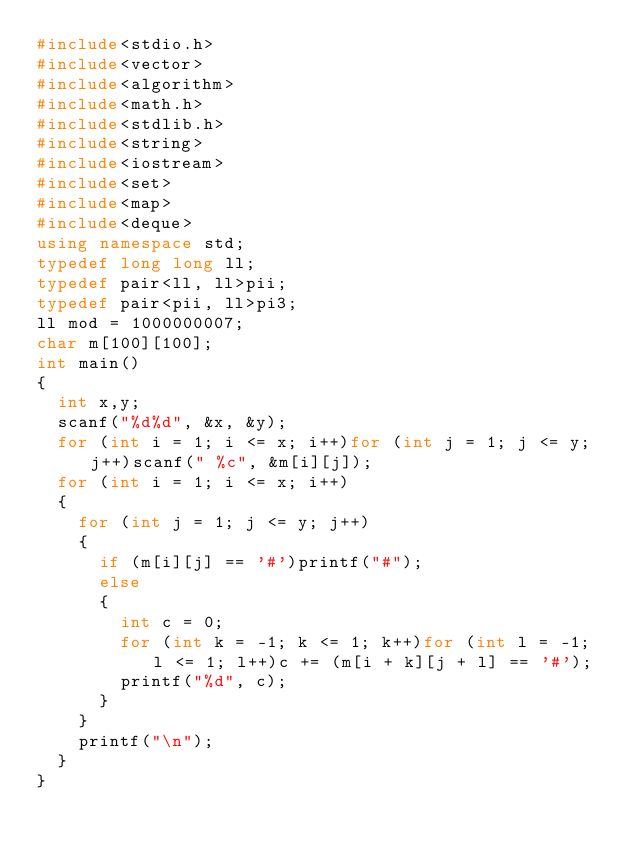Convert code to text. <code><loc_0><loc_0><loc_500><loc_500><_C++_>#include<stdio.h>
#include<vector>
#include<algorithm>
#include<math.h>
#include<stdlib.h>
#include<string>
#include<iostream>
#include<set>
#include<map>
#include<deque>
using namespace std;
typedef long long ll;
typedef pair<ll, ll>pii;
typedef pair<pii, ll>pi3;
ll mod = 1000000007;
char m[100][100];
int main()
{
	int x,y;
	scanf("%d%d", &x, &y);
	for (int i = 1; i <= x; i++)for (int j = 1; j <= y; j++)scanf(" %c", &m[i][j]);
	for (int i = 1; i <= x; i++)
	{
		for (int j = 1; j <= y; j++)
		{
			if (m[i][j] == '#')printf("#");
			else
			{
				int c = 0;
				for (int k = -1; k <= 1; k++)for (int l = -1; l <= 1; l++)c += (m[i + k][j + l] == '#');
				printf("%d", c);
			}
		}
		printf("\n");
	}
}</code> 